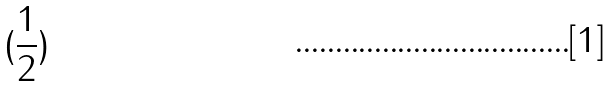<formula> <loc_0><loc_0><loc_500><loc_500>( \frac { 1 } { 2 } )</formula> 